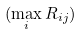Convert formula to latex. <formula><loc_0><loc_0><loc_500><loc_500>( \max _ { i } R _ { i j } )</formula> 